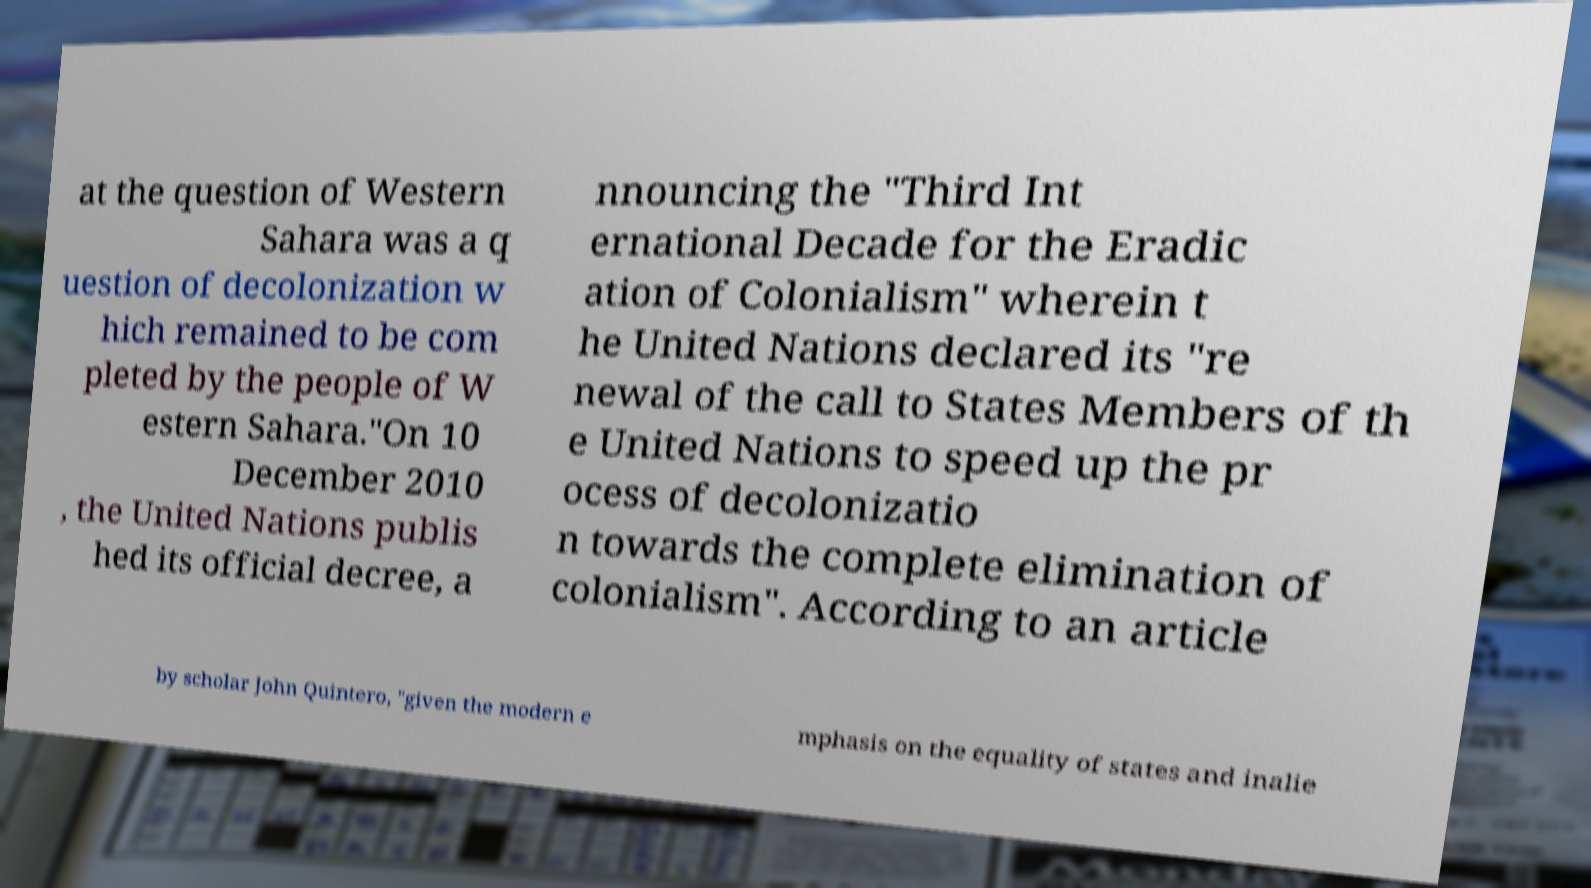Could you extract and type out the text from this image? at the question of Western Sahara was a q uestion of decolonization w hich remained to be com pleted by the people of W estern Sahara."On 10 December 2010 , the United Nations publis hed its official decree, a nnouncing the "Third Int ernational Decade for the Eradic ation of Colonialism" wherein t he United Nations declared its "re newal of the call to States Members of th e United Nations to speed up the pr ocess of decolonizatio n towards the complete elimination of colonialism". According to an article by scholar John Quintero, "given the modern e mphasis on the equality of states and inalie 